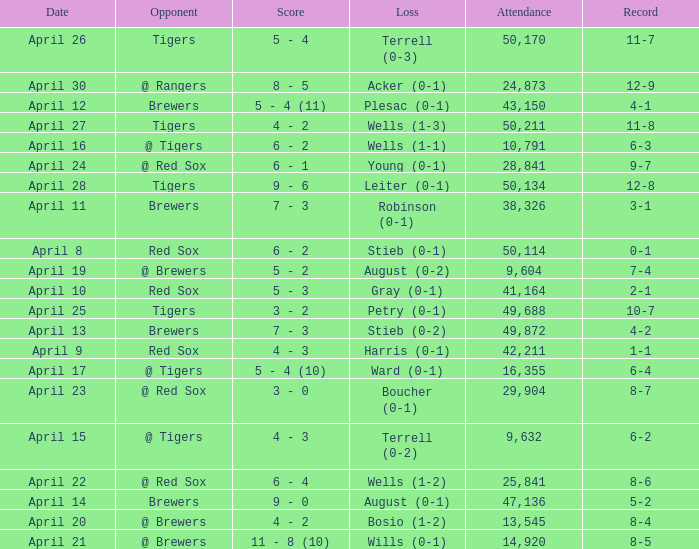What is the largest attendance that has tigers as the opponent and a loss of leiter (0-1)? 50134.0. 